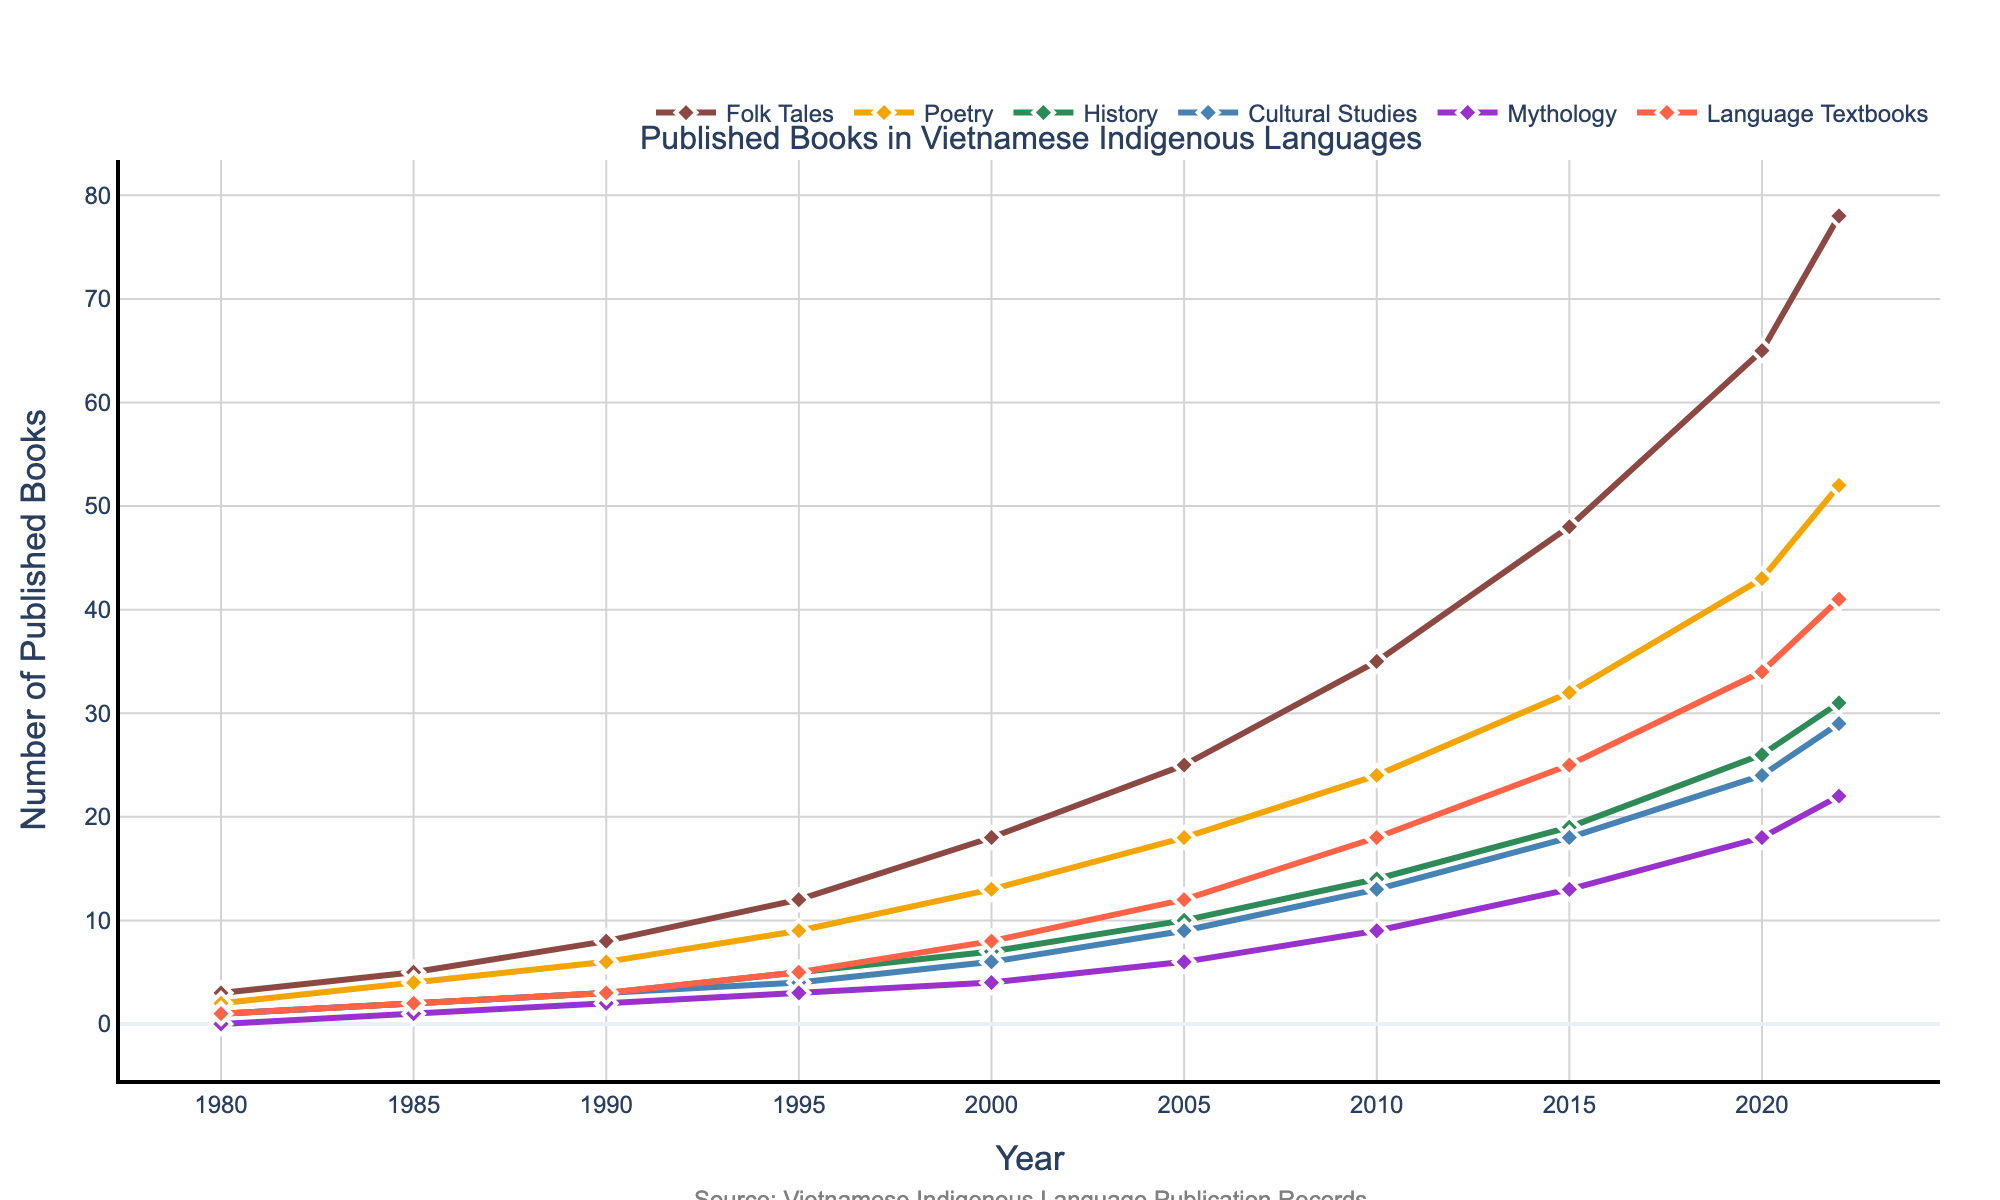What's the overall trend for the number of published books in Vietnamese indigenous languages from 1980 to 2022? The trend shows a general increase in the number of published books across all the genres from 1980 to 2022. Each genre has a distinct upward trajectory. For example, the number of Folk Tales books starts at 3 in 1980 and rises to 78 in 2022.
Answer: Increasing Which genre had the highest number of published books in 2022? By looking at the endpoints of the lines in the chart for 2022, we can see that Folk Tales had the highest count with 78 books published.
Answer: Folk Tales How many more Poetry books were published in 2020 compared to 1990? To find this, subtract the number of Poetry books published in 1990 (6) from the number published in 2020 (43): 43 - 6 = 37. So, 37 more Poetry books were published in 2020 compared to 1990.
Answer: 37 Which two genres had the smallest difference in the number of published books in 2022? In 2022, we can see that Mythology (22) and Cultural Studies (29) have the smallest difference. Subtracting 22 from 29 gives us a difference of 7.
Answer: Mythology and Cultural Studies What was the approximate average number of Language Textbooks published per year from 1980 to 2022? Summing up all the Language Textbooks published gives: 1 + 2 + 3 + 5 + 8 + 12 + 18 + 25 + 34 + 41 = 149. Then, divide this sum by the 10 recorded years to get the average: 149 / 10 = 14.9.
Answer: 14.9 Which genre had the greatest increase in the number of published books between 2010 and 2020? First, find the difference in the number of published books for each genre between 2010 and 2020. The increases are: Folk Tales (65 - 35 = 30), Poetry (43 - 24 = 19), History (26 - 14 = 12), Cultural Studies (24 - 13 = 11), Mythology (18 - 9 = 9), and Language Textbooks (34 - 18 = 16). The greatest increase is seen in Folk Tales with an increase of 30 books.
Answer: Folk Tales In which year did History books first surpass the count of Mythology books? We need to compare the counts year by year until History surpasses Mythology. In 2005, History (10) and Mythology (6). In 2010, History (14) and Mythology (9). Therefore, the first year History has more published books than Mythology is 2005.
Answer: 2005 What were the total number of published books across all genres in 2000? Sum the counts of all genres for the year 2000: 18 (Folk Tales) + 13 (Poetry) + 7 (History) + 6 (Cultural Studies) + 4 (Mythology) + 8 (Language Textbooks) = 56.
Answer: 56 How does the number of Poetry books published in 2000 compare to the number of Cultural Studies books published in 2020? The number of Poetry books in 2000 is 13, and the number of Cultural Studies books in 2020 is 24. Comparing these, 24 is greater than 13.
Answer: Cultural Studies in 2020 > Poetry in 2000 